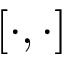Convert formula to latex. <formula><loc_0><loc_0><loc_500><loc_500>\left [ \cdot , \cdot \right ]</formula> 